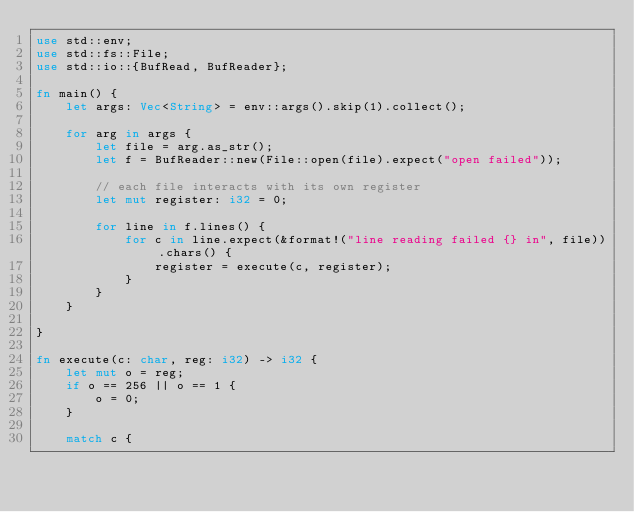<code> <loc_0><loc_0><loc_500><loc_500><_Rust_>use std::env;
use std::fs::File;
use std::io::{BufRead, BufReader};

fn main() {
    let args: Vec<String> = env::args().skip(1).collect();

    for arg in args {
        let file = arg.as_str();
        let f = BufReader::new(File::open(file).expect("open failed"));

        // each file interacts with its own register
        let mut register: i32 = 0;

        for line in f.lines() {
            for c in line.expect(&format!("line reading failed {} in", file)).chars() {
                register = execute(c, register);
            }
        }
    }

}

fn execute(c: char, reg: i32) -> i32 {
    let mut o = reg;
    if o == 256 || o == 1 { 
        o = 0;
    }

    match c {</code> 